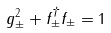<formula> <loc_0><loc_0><loc_500><loc_500>g _ { \pm } ^ { 2 } + f _ { \pm } ^ { \dagger } f _ { \pm } = 1</formula> 